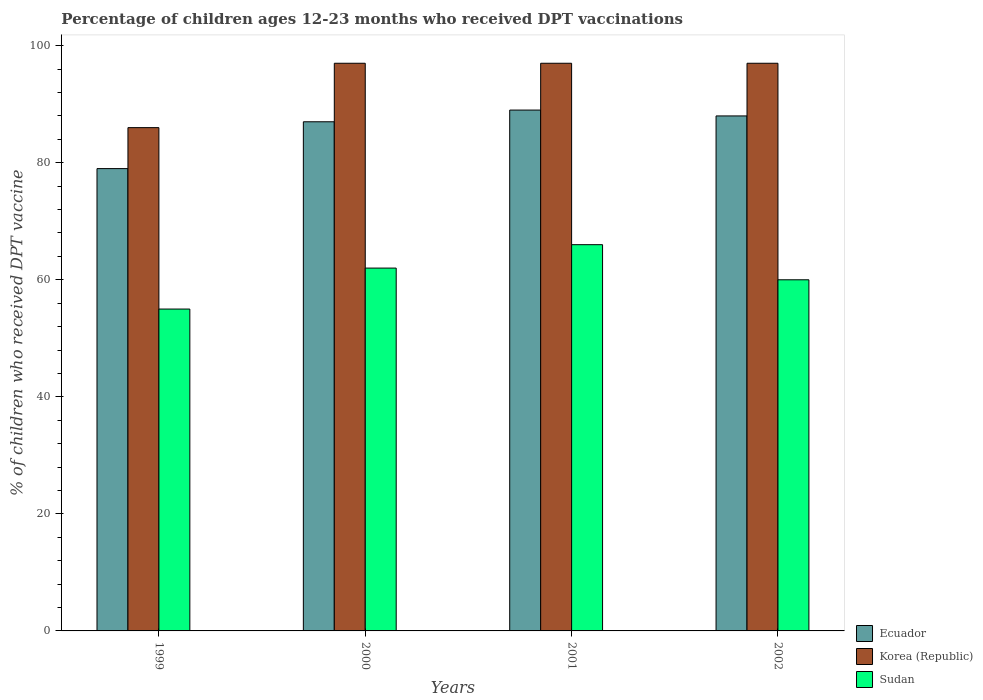Are the number of bars per tick equal to the number of legend labels?
Ensure brevity in your answer.  Yes. Are the number of bars on each tick of the X-axis equal?
Make the answer very short. Yes. What is the label of the 3rd group of bars from the left?
Provide a short and direct response. 2001. In how many cases, is the number of bars for a given year not equal to the number of legend labels?
Keep it short and to the point. 0. What is the percentage of children who received DPT vaccination in Sudan in 2002?
Ensure brevity in your answer.  60. Across all years, what is the maximum percentage of children who received DPT vaccination in Ecuador?
Make the answer very short. 89. In which year was the percentage of children who received DPT vaccination in Ecuador minimum?
Ensure brevity in your answer.  1999. What is the total percentage of children who received DPT vaccination in Korea (Republic) in the graph?
Offer a very short reply. 377. What is the difference between the percentage of children who received DPT vaccination in Korea (Republic) in 2000 and that in 2001?
Offer a very short reply. 0. What is the average percentage of children who received DPT vaccination in Korea (Republic) per year?
Provide a succinct answer. 94.25. In the year 2002, what is the difference between the percentage of children who received DPT vaccination in Sudan and percentage of children who received DPT vaccination in Ecuador?
Your answer should be very brief. -28. In how many years, is the percentage of children who received DPT vaccination in Korea (Republic) greater than 48 %?
Keep it short and to the point. 4. What is the ratio of the percentage of children who received DPT vaccination in Korea (Republic) in 1999 to that in 2000?
Ensure brevity in your answer.  0.89. In how many years, is the percentage of children who received DPT vaccination in Ecuador greater than the average percentage of children who received DPT vaccination in Ecuador taken over all years?
Your response must be concise. 3. Is the sum of the percentage of children who received DPT vaccination in Sudan in 1999 and 2000 greater than the maximum percentage of children who received DPT vaccination in Korea (Republic) across all years?
Offer a terse response. Yes. What does the 1st bar from the left in 2001 represents?
Your response must be concise. Ecuador. What does the 1st bar from the right in 2002 represents?
Offer a terse response. Sudan. Are all the bars in the graph horizontal?
Your response must be concise. No. How many years are there in the graph?
Your answer should be very brief. 4. Does the graph contain any zero values?
Provide a succinct answer. No. Where does the legend appear in the graph?
Ensure brevity in your answer.  Bottom right. How many legend labels are there?
Keep it short and to the point. 3. What is the title of the graph?
Provide a succinct answer. Percentage of children ages 12-23 months who received DPT vaccinations. What is the label or title of the X-axis?
Offer a very short reply. Years. What is the label or title of the Y-axis?
Make the answer very short. % of children who received DPT vaccine. What is the % of children who received DPT vaccine of Ecuador in 1999?
Your answer should be very brief. 79. What is the % of children who received DPT vaccine of Korea (Republic) in 1999?
Offer a very short reply. 86. What is the % of children who received DPT vaccine of Sudan in 1999?
Ensure brevity in your answer.  55. What is the % of children who received DPT vaccine of Ecuador in 2000?
Ensure brevity in your answer.  87. What is the % of children who received DPT vaccine in Korea (Republic) in 2000?
Ensure brevity in your answer.  97. What is the % of children who received DPT vaccine of Ecuador in 2001?
Your answer should be compact. 89. What is the % of children who received DPT vaccine of Korea (Republic) in 2001?
Your answer should be very brief. 97. What is the % of children who received DPT vaccine of Sudan in 2001?
Make the answer very short. 66. What is the % of children who received DPT vaccine in Ecuador in 2002?
Ensure brevity in your answer.  88. What is the % of children who received DPT vaccine of Korea (Republic) in 2002?
Offer a very short reply. 97. Across all years, what is the maximum % of children who received DPT vaccine in Ecuador?
Your answer should be very brief. 89. Across all years, what is the maximum % of children who received DPT vaccine in Korea (Republic)?
Provide a short and direct response. 97. Across all years, what is the maximum % of children who received DPT vaccine in Sudan?
Offer a terse response. 66. Across all years, what is the minimum % of children who received DPT vaccine in Ecuador?
Provide a short and direct response. 79. What is the total % of children who received DPT vaccine of Ecuador in the graph?
Offer a terse response. 343. What is the total % of children who received DPT vaccine in Korea (Republic) in the graph?
Your answer should be compact. 377. What is the total % of children who received DPT vaccine of Sudan in the graph?
Your answer should be very brief. 243. What is the difference between the % of children who received DPT vaccine in Ecuador in 1999 and that in 2000?
Provide a short and direct response. -8. What is the difference between the % of children who received DPT vaccine in Sudan in 1999 and that in 2000?
Offer a very short reply. -7. What is the difference between the % of children who received DPT vaccine in Ecuador in 1999 and that in 2001?
Keep it short and to the point. -10. What is the difference between the % of children who received DPT vaccine of Sudan in 1999 and that in 2001?
Make the answer very short. -11. What is the difference between the % of children who received DPT vaccine of Korea (Republic) in 1999 and that in 2002?
Your answer should be very brief. -11. What is the difference between the % of children who received DPT vaccine in Korea (Republic) in 2000 and that in 2001?
Provide a succinct answer. 0. What is the difference between the % of children who received DPT vaccine of Ecuador in 2001 and that in 2002?
Keep it short and to the point. 1. What is the difference between the % of children who received DPT vaccine in Korea (Republic) in 2001 and that in 2002?
Your response must be concise. 0. What is the difference between the % of children who received DPT vaccine of Ecuador in 1999 and the % of children who received DPT vaccine of Sudan in 2002?
Provide a short and direct response. 19. What is the difference between the % of children who received DPT vaccine of Korea (Republic) in 1999 and the % of children who received DPT vaccine of Sudan in 2002?
Your answer should be very brief. 26. What is the difference between the % of children who received DPT vaccine in Ecuador in 2000 and the % of children who received DPT vaccine in Korea (Republic) in 2001?
Ensure brevity in your answer.  -10. What is the difference between the % of children who received DPT vaccine of Ecuador in 2000 and the % of children who received DPT vaccine of Sudan in 2001?
Your response must be concise. 21. What is the difference between the % of children who received DPT vaccine in Ecuador in 2000 and the % of children who received DPT vaccine in Korea (Republic) in 2002?
Your answer should be very brief. -10. What is the difference between the % of children who received DPT vaccine in Ecuador in 2000 and the % of children who received DPT vaccine in Sudan in 2002?
Your answer should be very brief. 27. What is the difference between the % of children who received DPT vaccine in Korea (Republic) in 2000 and the % of children who received DPT vaccine in Sudan in 2002?
Keep it short and to the point. 37. What is the difference between the % of children who received DPT vaccine of Ecuador in 2001 and the % of children who received DPT vaccine of Korea (Republic) in 2002?
Make the answer very short. -8. What is the average % of children who received DPT vaccine in Ecuador per year?
Provide a succinct answer. 85.75. What is the average % of children who received DPT vaccine of Korea (Republic) per year?
Your response must be concise. 94.25. What is the average % of children who received DPT vaccine of Sudan per year?
Provide a short and direct response. 60.75. In the year 1999, what is the difference between the % of children who received DPT vaccine in Ecuador and % of children who received DPT vaccine in Korea (Republic)?
Offer a very short reply. -7. In the year 1999, what is the difference between the % of children who received DPT vaccine in Ecuador and % of children who received DPT vaccine in Sudan?
Provide a succinct answer. 24. In the year 2000, what is the difference between the % of children who received DPT vaccine of Ecuador and % of children who received DPT vaccine of Korea (Republic)?
Provide a short and direct response. -10. In the year 2000, what is the difference between the % of children who received DPT vaccine of Ecuador and % of children who received DPT vaccine of Sudan?
Ensure brevity in your answer.  25. In the year 2001, what is the difference between the % of children who received DPT vaccine of Ecuador and % of children who received DPT vaccine of Korea (Republic)?
Offer a terse response. -8. In the year 2001, what is the difference between the % of children who received DPT vaccine of Ecuador and % of children who received DPT vaccine of Sudan?
Provide a succinct answer. 23. In the year 2002, what is the difference between the % of children who received DPT vaccine in Korea (Republic) and % of children who received DPT vaccine in Sudan?
Your answer should be very brief. 37. What is the ratio of the % of children who received DPT vaccine of Ecuador in 1999 to that in 2000?
Provide a short and direct response. 0.91. What is the ratio of the % of children who received DPT vaccine of Korea (Republic) in 1999 to that in 2000?
Provide a succinct answer. 0.89. What is the ratio of the % of children who received DPT vaccine of Sudan in 1999 to that in 2000?
Your answer should be compact. 0.89. What is the ratio of the % of children who received DPT vaccine of Ecuador in 1999 to that in 2001?
Your response must be concise. 0.89. What is the ratio of the % of children who received DPT vaccine of Korea (Republic) in 1999 to that in 2001?
Offer a very short reply. 0.89. What is the ratio of the % of children who received DPT vaccine in Sudan in 1999 to that in 2001?
Give a very brief answer. 0.83. What is the ratio of the % of children who received DPT vaccine in Ecuador in 1999 to that in 2002?
Give a very brief answer. 0.9. What is the ratio of the % of children who received DPT vaccine in Korea (Republic) in 1999 to that in 2002?
Make the answer very short. 0.89. What is the ratio of the % of children who received DPT vaccine in Ecuador in 2000 to that in 2001?
Ensure brevity in your answer.  0.98. What is the ratio of the % of children who received DPT vaccine in Korea (Republic) in 2000 to that in 2001?
Ensure brevity in your answer.  1. What is the ratio of the % of children who received DPT vaccine of Sudan in 2000 to that in 2001?
Your answer should be compact. 0.94. What is the ratio of the % of children who received DPT vaccine of Sudan in 2000 to that in 2002?
Offer a terse response. 1.03. What is the ratio of the % of children who received DPT vaccine in Ecuador in 2001 to that in 2002?
Your response must be concise. 1.01. What is the ratio of the % of children who received DPT vaccine of Sudan in 2001 to that in 2002?
Make the answer very short. 1.1. What is the difference between the highest and the lowest % of children who received DPT vaccine in Sudan?
Keep it short and to the point. 11. 